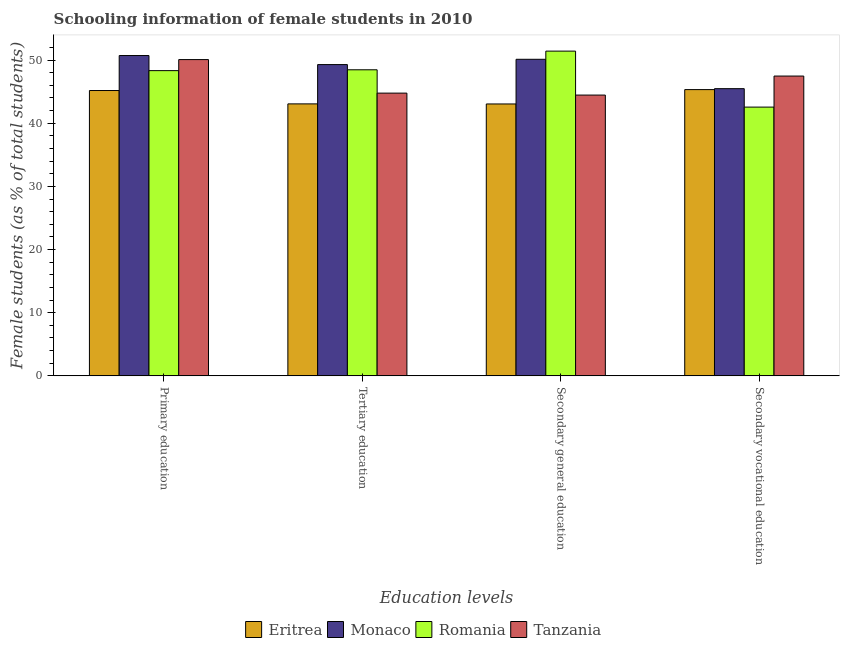How many groups of bars are there?
Your answer should be compact. 4. Are the number of bars per tick equal to the number of legend labels?
Ensure brevity in your answer.  Yes. Are the number of bars on each tick of the X-axis equal?
Provide a short and direct response. Yes. What is the label of the 2nd group of bars from the left?
Your answer should be compact. Tertiary education. What is the percentage of female students in secondary education in Romania?
Offer a terse response. 51.42. Across all countries, what is the maximum percentage of female students in tertiary education?
Keep it short and to the point. 49.28. Across all countries, what is the minimum percentage of female students in tertiary education?
Make the answer very short. 43.06. In which country was the percentage of female students in secondary vocational education maximum?
Provide a succinct answer. Tanzania. In which country was the percentage of female students in tertiary education minimum?
Give a very brief answer. Eritrea. What is the total percentage of female students in tertiary education in the graph?
Your answer should be very brief. 185.57. What is the difference between the percentage of female students in tertiary education in Eritrea and that in Romania?
Provide a short and direct response. -5.4. What is the difference between the percentage of female students in tertiary education in Eritrea and the percentage of female students in secondary education in Tanzania?
Ensure brevity in your answer.  -1.4. What is the average percentage of female students in secondary education per country?
Keep it short and to the point. 47.26. What is the difference between the percentage of female students in secondary education and percentage of female students in tertiary education in Eritrea?
Your answer should be compact. -0.01. What is the ratio of the percentage of female students in secondary education in Monaco to that in Romania?
Provide a short and direct response. 0.97. What is the difference between the highest and the second highest percentage of female students in tertiary education?
Your response must be concise. 0.82. What is the difference between the highest and the lowest percentage of female students in secondary education?
Your answer should be compact. 8.37. Is the sum of the percentage of female students in secondary vocational education in Romania and Eritrea greater than the maximum percentage of female students in tertiary education across all countries?
Your answer should be compact. Yes. Is it the case that in every country, the sum of the percentage of female students in primary education and percentage of female students in tertiary education is greater than the sum of percentage of female students in secondary vocational education and percentage of female students in secondary education?
Keep it short and to the point. No. What does the 3rd bar from the left in Secondary vocational education represents?
Your answer should be compact. Romania. What does the 1st bar from the right in Primary education represents?
Offer a very short reply. Tanzania. Is it the case that in every country, the sum of the percentage of female students in primary education and percentage of female students in tertiary education is greater than the percentage of female students in secondary education?
Your answer should be very brief. Yes. How many bars are there?
Make the answer very short. 16. How many countries are there in the graph?
Make the answer very short. 4. Does the graph contain any zero values?
Provide a short and direct response. No. What is the title of the graph?
Offer a very short reply. Schooling information of female students in 2010. What is the label or title of the X-axis?
Ensure brevity in your answer.  Education levels. What is the label or title of the Y-axis?
Provide a short and direct response. Female students (as % of total students). What is the Female students (as % of total students) in Eritrea in Primary education?
Your answer should be very brief. 45.18. What is the Female students (as % of total students) of Monaco in Primary education?
Keep it short and to the point. 50.71. What is the Female students (as % of total students) in Romania in Primary education?
Your answer should be compact. 48.33. What is the Female students (as % of total students) in Tanzania in Primary education?
Provide a short and direct response. 50.08. What is the Female students (as % of total students) of Eritrea in Tertiary education?
Offer a terse response. 43.06. What is the Female students (as % of total students) of Monaco in Tertiary education?
Provide a short and direct response. 49.28. What is the Female students (as % of total students) in Romania in Tertiary education?
Ensure brevity in your answer.  48.46. What is the Female students (as % of total students) in Tanzania in Tertiary education?
Provide a short and direct response. 44.77. What is the Female students (as % of total students) of Eritrea in Secondary general education?
Make the answer very short. 43.05. What is the Female students (as % of total students) of Monaco in Secondary general education?
Ensure brevity in your answer.  50.12. What is the Female students (as % of total students) in Romania in Secondary general education?
Your answer should be compact. 51.42. What is the Female students (as % of total students) in Tanzania in Secondary general education?
Give a very brief answer. 44.46. What is the Female students (as % of total students) in Eritrea in Secondary vocational education?
Keep it short and to the point. 45.32. What is the Female students (as % of total students) in Monaco in Secondary vocational education?
Provide a succinct answer. 45.47. What is the Female students (as % of total students) of Romania in Secondary vocational education?
Offer a terse response. 42.55. What is the Female students (as % of total students) in Tanzania in Secondary vocational education?
Provide a short and direct response. 47.47. Across all Education levels, what is the maximum Female students (as % of total students) in Eritrea?
Give a very brief answer. 45.32. Across all Education levels, what is the maximum Female students (as % of total students) in Monaco?
Make the answer very short. 50.71. Across all Education levels, what is the maximum Female students (as % of total students) of Romania?
Make the answer very short. 51.42. Across all Education levels, what is the maximum Female students (as % of total students) in Tanzania?
Your answer should be compact. 50.08. Across all Education levels, what is the minimum Female students (as % of total students) in Eritrea?
Offer a terse response. 43.05. Across all Education levels, what is the minimum Female students (as % of total students) in Monaco?
Provide a short and direct response. 45.47. Across all Education levels, what is the minimum Female students (as % of total students) of Romania?
Offer a very short reply. 42.55. Across all Education levels, what is the minimum Female students (as % of total students) in Tanzania?
Provide a short and direct response. 44.46. What is the total Female students (as % of total students) in Eritrea in the graph?
Offer a very short reply. 176.61. What is the total Female students (as % of total students) of Monaco in the graph?
Provide a short and direct response. 195.59. What is the total Female students (as % of total students) in Romania in the graph?
Make the answer very short. 190.75. What is the total Female students (as % of total students) in Tanzania in the graph?
Give a very brief answer. 186.77. What is the difference between the Female students (as % of total students) in Eritrea in Primary education and that in Tertiary education?
Your answer should be compact. 2.12. What is the difference between the Female students (as % of total students) in Monaco in Primary education and that in Tertiary education?
Your answer should be very brief. 1.43. What is the difference between the Female students (as % of total students) in Romania in Primary education and that in Tertiary education?
Make the answer very short. -0.13. What is the difference between the Female students (as % of total students) in Tanzania in Primary education and that in Tertiary education?
Your response must be concise. 5.31. What is the difference between the Female students (as % of total students) in Eritrea in Primary education and that in Secondary general education?
Keep it short and to the point. 2.13. What is the difference between the Female students (as % of total students) in Monaco in Primary education and that in Secondary general education?
Give a very brief answer. 0.59. What is the difference between the Female students (as % of total students) of Romania in Primary education and that in Secondary general education?
Ensure brevity in your answer.  -3.09. What is the difference between the Female students (as % of total students) in Tanzania in Primary education and that in Secondary general education?
Keep it short and to the point. 5.62. What is the difference between the Female students (as % of total students) of Eritrea in Primary education and that in Secondary vocational education?
Keep it short and to the point. -0.14. What is the difference between the Female students (as % of total students) in Monaco in Primary education and that in Secondary vocational education?
Make the answer very short. 5.24. What is the difference between the Female students (as % of total students) of Romania in Primary education and that in Secondary vocational education?
Make the answer very short. 5.77. What is the difference between the Female students (as % of total students) in Tanzania in Primary education and that in Secondary vocational education?
Provide a succinct answer. 2.61. What is the difference between the Female students (as % of total students) in Eritrea in Tertiary education and that in Secondary general education?
Offer a terse response. 0.01. What is the difference between the Female students (as % of total students) in Monaco in Tertiary education and that in Secondary general education?
Give a very brief answer. -0.84. What is the difference between the Female students (as % of total students) in Romania in Tertiary education and that in Secondary general education?
Provide a succinct answer. -2.96. What is the difference between the Female students (as % of total students) of Tanzania in Tertiary education and that in Secondary general education?
Provide a short and direct response. 0.31. What is the difference between the Female students (as % of total students) of Eritrea in Tertiary education and that in Secondary vocational education?
Your answer should be very brief. -2.26. What is the difference between the Female students (as % of total students) in Monaco in Tertiary education and that in Secondary vocational education?
Your response must be concise. 3.81. What is the difference between the Female students (as % of total students) in Romania in Tertiary education and that in Secondary vocational education?
Provide a succinct answer. 5.91. What is the difference between the Female students (as % of total students) of Tanzania in Tertiary education and that in Secondary vocational education?
Offer a very short reply. -2.7. What is the difference between the Female students (as % of total students) in Eritrea in Secondary general education and that in Secondary vocational education?
Keep it short and to the point. -2.27. What is the difference between the Female students (as % of total students) in Monaco in Secondary general education and that in Secondary vocational education?
Your answer should be compact. 4.65. What is the difference between the Female students (as % of total students) in Romania in Secondary general education and that in Secondary vocational education?
Provide a succinct answer. 8.86. What is the difference between the Female students (as % of total students) of Tanzania in Secondary general education and that in Secondary vocational education?
Provide a short and direct response. -3.01. What is the difference between the Female students (as % of total students) of Eritrea in Primary education and the Female students (as % of total students) of Monaco in Tertiary education?
Provide a succinct answer. -4.11. What is the difference between the Female students (as % of total students) of Eritrea in Primary education and the Female students (as % of total students) of Romania in Tertiary education?
Provide a short and direct response. -3.28. What is the difference between the Female students (as % of total students) in Eritrea in Primary education and the Female students (as % of total students) in Tanzania in Tertiary education?
Your answer should be very brief. 0.41. What is the difference between the Female students (as % of total students) of Monaco in Primary education and the Female students (as % of total students) of Romania in Tertiary education?
Offer a terse response. 2.26. What is the difference between the Female students (as % of total students) of Monaco in Primary education and the Female students (as % of total students) of Tanzania in Tertiary education?
Provide a succinct answer. 5.95. What is the difference between the Female students (as % of total students) in Romania in Primary education and the Female students (as % of total students) in Tanzania in Tertiary education?
Your response must be concise. 3.56. What is the difference between the Female students (as % of total students) in Eritrea in Primary education and the Female students (as % of total students) in Monaco in Secondary general education?
Provide a succinct answer. -4.94. What is the difference between the Female students (as % of total students) in Eritrea in Primary education and the Female students (as % of total students) in Romania in Secondary general education?
Ensure brevity in your answer.  -6.24. What is the difference between the Female students (as % of total students) of Eritrea in Primary education and the Female students (as % of total students) of Tanzania in Secondary general education?
Your response must be concise. 0.72. What is the difference between the Female students (as % of total students) in Monaco in Primary education and the Female students (as % of total students) in Romania in Secondary general education?
Your response must be concise. -0.7. What is the difference between the Female students (as % of total students) of Monaco in Primary education and the Female students (as % of total students) of Tanzania in Secondary general education?
Provide a short and direct response. 6.26. What is the difference between the Female students (as % of total students) of Romania in Primary education and the Female students (as % of total students) of Tanzania in Secondary general education?
Provide a succinct answer. 3.87. What is the difference between the Female students (as % of total students) of Eritrea in Primary education and the Female students (as % of total students) of Monaco in Secondary vocational education?
Your answer should be very brief. -0.29. What is the difference between the Female students (as % of total students) of Eritrea in Primary education and the Female students (as % of total students) of Romania in Secondary vocational education?
Provide a succinct answer. 2.63. What is the difference between the Female students (as % of total students) in Eritrea in Primary education and the Female students (as % of total students) in Tanzania in Secondary vocational education?
Offer a very short reply. -2.29. What is the difference between the Female students (as % of total students) in Monaco in Primary education and the Female students (as % of total students) in Romania in Secondary vocational education?
Your response must be concise. 8.16. What is the difference between the Female students (as % of total students) in Monaco in Primary education and the Female students (as % of total students) in Tanzania in Secondary vocational education?
Your response must be concise. 3.25. What is the difference between the Female students (as % of total students) in Romania in Primary education and the Female students (as % of total students) in Tanzania in Secondary vocational education?
Ensure brevity in your answer.  0.86. What is the difference between the Female students (as % of total students) in Eritrea in Tertiary education and the Female students (as % of total students) in Monaco in Secondary general education?
Offer a very short reply. -7.06. What is the difference between the Female students (as % of total students) in Eritrea in Tertiary education and the Female students (as % of total students) in Romania in Secondary general education?
Make the answer very short. -8.36. What is the difference between the Female students (as % of total students) of Eritrea in Tertiary education and the Female students (as % of total students) of Tanzania in Secondary general education?
Offer a very short reply. -1.4. What is the difference between the Female students (as % of total students) of Monaco in Tertiary education and the Female students (as % of total students) of Romania in Secondary general education?
Your response must be concise. -2.13. What is the difference between the Female students (as % of total students) of Monaco in Tertiary education and the Female students (as % of total students) of Tanzania in Secondary general education?
Give a very brief answer. 4.83. What is the difference between the Female students (as % of total students) in Romania in Tertiary education and the Female students (as % of total students) in Tanzania in Secondary general education?
Give a very brief answer. 4. What is the difference between the Female students (as % of total students) of Eritrea in Tertiary education and the Female students (as % of total students) of Monaco in Secondary vocational education?
Your response must be concise. -2.41. What is the difference between the Female students (as % of total students) in Eritrea in Tertiary education and the Female students (as % of total students) in Romania in Secondary vocational education?
Offer a very short reply. 0.51. What is the difference between the Female students (as % of total students) in Eritrea in Tertiary education and the Female students (as % of total students) in Tanzania in Secondary vocational education?
Your answer should be very brief. -4.41. What is the difference between the Female students (as % of total students) of Monaco in Tertiary education and the Female students (as % of total students) of Romania in Secondary vocational education?
Your answer should be very brief. 6.73. What is the difference between the Female students (as % of total students) of Monaco in Tertiary education and the Female students (as % of total students) of Tanzania in Secondary vocational education?
Keep it short and to the point. 1.81. What is the difference between the Female students (as % of total students) in Eritrea in Secondary general education and the Female students (as % of total students) in Monaco in Secondary vocational education?
Ensure brevity in your answer.  -2.42. What is the difference between the Female students (as % of total students) of Eritrea in Secondary general education and the Female students (as % of total students) of Romania in Secondary vocational education?
Your answer should be compact. 0.5. What is the difference between the Female students (as % of total students) in Eritrea in Secondary general education and the Female students (as % of total students) in Tanzania in Secondary vocational education?
Offer a terse response. -4.42. What is the difference between the Female students (as % of total students) in Monaco in Secondary general education and the Female students (as % of total students) in Romania in Secondary vocational education?
Keep it short and to the point. 7.57. What is the difference between the Female students (as % of total students) of Monaco in Secondary general education and the Female students (as % of total students) of Tanzania in Secondary vocational education?
Your answer should be compact. 2.65. What is the difference between the Female students (as % of total students) in Romania in Secondary general education and the Female students (as % of total students) in Tanzania in Secondary vocational education?
Provide a short and direct response. 3.95. What is the average Female students (as % of total students) of Eritrea per Education levels?
Your response must be concise. 44.15. What is the average Female students (as % of total students) in Monaco per Education levels?
Give a very brief answer. 48.9. What is the average Female students (as % of total students) of Romania per Education levels?
Your answer should be compact. 47.69. What is the average Female students (as % of total students) of Tanzania per Education levels?
Provide a short and direct response. 46.69. What is the difference between the Female students (as % of total students) of Eritrea and Female students (as % of total students) of Monaco in Primary education?
Offer a very short reply. -5.54. What is the difference between the Female students (as % of total students) in Eritrea and Female students (as % of total students) in Romania in Primary education?
Offer a terse response. -3.15. What is the difference between the Female students (as % of total students) of Eritrea and Female students (as % of total students) of Tanzania in Primary education?
Offer a terse response. -4.9. What is the difference between the Female students (as % of total students) in Monaco and Female students (as % of total students) in Romania in Primary education?
Make the answer very short. 2.39. What is the difference between the Female students (as % of total students) of Monaco and Female students (as % of total students) of Tanzania in Primary education?
Make the answer very short. 0.64. What is the difference between the Female students (as % of total students) of Romania and Female students (as % of total students) of Tanzania in Primary education?
Offer a very short reply. -1.75. What is the difference between the Female students (as % of total students) of Eritrea and Female students (as % of total students) of Monaco in Tertiary education?
Offer a terse response. -6.22. What is the difference between the Female students (as % of total students) of Eritrea and Female students (as % of total students) of Romania in Tertiary education?
Keep it short and to the point. -5.4. What is the difference between the Female students (as % of total students) of Eritrea and Female students (as % of total students) of Tanzania in Tertiary education?
Make the answer very short. -1.71. What is the difference between the Female students (as % of total students) in Monaco and Female students (as % of total students) in Romania in Tertiary education?
Your response must be concise. 0.82. What is the difference between the Female students (as % of total students) of Monaco and Female students (as % of total students) of Tanzania in Tertiary education?
Offer a very short reply. 4.52. What is the difference between the Female students (as % of total students) in Romania and Female students (as % of total students) in Tanzania in Tertiary education?
Keep it short and to the point. 3.69. What is the difference between the Female students (as % of total students) of Eritrea and Female students (as % of total students) of Monaco in Secondary general education?
Offer a terse response. -7.07. What is the difference between the Female students (as % of total students) in Eritrea and Female students (as % of total students) in Romania in Secondary general education?
Make the answer very short. -8.37. What is the difference between the Female students (as % of total students) of Eritrea and Female students (as % of total students) of Tanzania in Secondary general education?
Provide a succinct answer. -1.41. What is the difference between the Female students (as % of total students) in Monaco and Female students (as % of total students) in Romania in Secondary general education?
Your response must be concise. -1.29. What is the difference between the Female students (as % of total students) in Monaco and Female students (as % of total students) in Tanzania in Secondary general education?
Keep it short and to the point. 5.66. What is the difference between the Female students (as % of total students) in Romania and Female students (as % of total students) in Tanzania in Secondary general education?
Provide a short and direct response. 6.96. What is the difference between the Female students (as % of total students) of Eritrea and Female students (as % of total students) of Monaco in Secondary vocational education?
Provide a short and direct response. -0.15. What is the difference between the Female students (as % of total students) of Eritrea and Female students (as % of total students) of Romania in Secondary vocational education?
Provide a short and direct response. 2.77. What is the difference between the Female students (as % of total students) of Eritrea and Female students (as % of total students) of Tanzania in Secondary vocational education?
Provide a succinct answer. -2.15. What is the difference between the Female students (as % of total students) of Monaco and Female students (as % of total students) of Romania in Secondary vocational education?
Make the answer very short. 2.92. What is the difference between the Female students (as % of total students) in Monaco and Female students (as % of total students) in Tanzania in Secondary vocational education?
Provide a short and direct response. -2. What is the difference between the Female students (as % of total students) in Romania and Female students (as % of total students) in Tanzania in Secondary vocational education?
Provide a short and direct response. -4.92. What is the ratio of the Female students (as % of total students) in Eritrea in Primary education to that in Tertiary education?
Offer a very short reply. 1.05. What is the ratio of the Female students (as % of total students) of Tanzania in Primary education to that in Tertiary education?
Make the answer very short. 1.12. What is the ratio of the Female students (as % of total students) in Eritrea in Primary education to that in Secondary general education?
Ensure brevity in your answer.  1.05. What is the ratio of the Female students (as % of total students) of Monaco in Primary education to that in Secondary general education?
Offer a very short reply. 1.01. What is the ratio of the Female students (as % of total students) of Romania in Primary education to that in Secondary general education?
Offer a terse response. 0.94. What is the ratio of the Female students (as % of total students) of Tanzania in Primary education to that in Secondary general education?
Your answer should be very brief. 1.13. What is the ratio of the Female students (as % of total students) in Monaco in Primary education to that in Secondary vocational education?
Provide a succinct answer. 1.12. What is the ratio of the Female students (as % of total students) of Romania in Primary education to that in Secondary vocational education?
Ensure brevity in your answer.  1.14. What is the ratio of the Female students (as % of total students) in Tanzania in Primary education to that in Secondary vocational education?
Offer a very short reply. 1.05. What is the ratio of the Female students (as % of total students) in Monaco in Tertiary education to that in Secondary general education?
Your answer should be very brief. 0.98. What is the ratio of the Female students (as % of total students) in Romania in Tertiary education to that in Secondary general education?
Provide a succinct answer. 0.94. What is the ratio of the Female students (as % of total students) in Tanzania in Tertiary education to that in Secondary general education?
Your answer should be compact. 1.01. What is the ratio of the Female students (as % of total students) in Eritrea in Tertiary education to that in Secondary vocational education?
Your answer should be very brief. 0.95. What is the ratio of the Female students (as % of total students) in Monaco in Tertiary education to that in Secondary vocational education?
Provide a succinct answer. 1.08. What is the ratio of the Female students (as % of total students) in Romania in Tertiary education to that in Secondary vocational education?
Make the answer very short. 1.14. What is the ratio of the Female students (as % of total students) of Tanzania in Tertiary education to that in Secondary vocational education?
Offer a terse response. 0.94. What is the ratio of the Female students (as % of total students) in Eritrea in Secondary general education to that in Secondary vocational education?
Offer a very short reply. 0.95. What is the ratio of the Female students (as % of total students) of Monaco in Secondary general education to that in Secondary vocational education?
Keep it short and to the point. 1.1. What is the ratio of the Female students (as % of total students) of Romania in Secondary general education to that in Secondary vocational education?
Give a very brief answer. 1.21. What is the ratio of the Female students (as % of total students) in Tanzania in Secondary general education to that in Secondary vocational education?
Provide a succinct answer. 0.94. What is the difference between the highest and the second highest Female students (as % of total students) in Eritrea?
Give a very brief answer. 0.14. What is the difference between the highest and the second highest Female students (as % of total students) in Monaco?
Your answer should be very brief. 0.59. What is the difference between the highest and the second highest Female students (as % of total students) of Romania?
Ensure brevity in your answer.  2.96. What is the difference between the highest and the second highest Female students (as % of total students) in Tanzania?
Your answer should be very brief. 2.61. What is the difference between the highest and the lowest Female students (as % of total students) of Eritrea?
Your response must be concise. 2.27. What is the difference between the highest and the lowest Female students (as % of total students) of Monaco?
Ensure brevity in your answer.  5.24. What is the difference between the highest and the lowest Female students (as % of total students) of Romania?
Offer a terse response. 8.86. What is the difference between the highest and the lowest Female students (as % of total students) in Tanzania?
Provide a short and direct response. 5.62. 